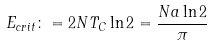<formula> <loc_0><loc_0><loc_500><loc_500>E _ { c r i t } \colon = 2 N T _ { C } \ln 2 = \frac { N a \ln 2 } { \pi }</formula> 